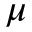<formula> <loc_0><loc_0><loc_500><loc_500>\mu</formula> 